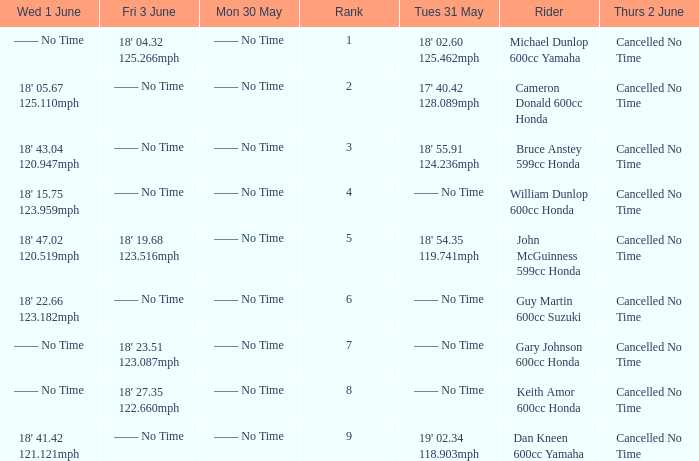Who was the rider with a Fri 3 June time of 18' 19.68 123.516mph? John McGuinness 599cc Honda. 